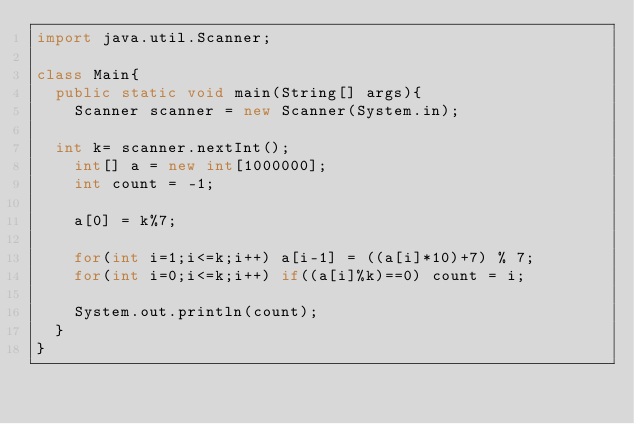<code> <loc_0><loc_0><loc_500><loc_500><_Java_>import java.util.Scanner;

class Main{
  public static void main(String[] args){
  	Scanner scanner = new Scanner(System.in);

	int k= scanner.nextInt();
    int[] a = new int[1000000];
    int count = -1;
    
    a[0] = k%7;
    
    for(int i=1;i<=k;i++) a[i-1] = ((a[i]*10)+7) % 7;
    for(int i=0;i<=k;i++) if((a[i]%k)==0) count = i;
    
    System.out.println(count);
  }
}</code> 